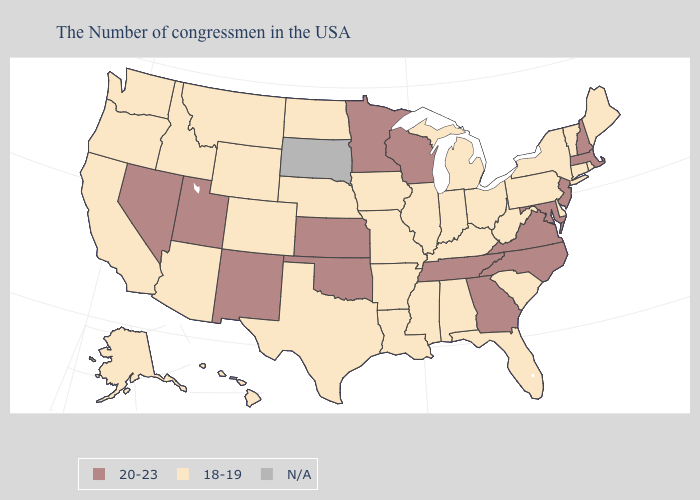Does the first symbol in the legend represent the smallest category?
Write a very short answer. No. Name the states that have a value in the range N/A?
Concise answer only. South Dakota. Name the states that have a value in the range N/A?
Short answer required. South Dakota. Name the states that have a value in the range 18-19?
Quick response, please. Maine, Rhode Island, Vermont, Connecticut, New York, Delaware, Pennsylvania, South Carolina, West Virginia, Ohio, Florida, Michigan, Kentucky, Indiana, Alabama, Illinois, Mississippi, Louisiana, Missouri, Arkansas, Iowa, Nebraska, Texas, North Dakota, Wyoming, Colorado, Montana, Arizona, Idaho, California, Washington, Oregon, Alaska, Hawaii. Does Montana have the lowest value in the West?
Keep it brief. Yes. Name the states that have a value in the range 18-19?
Answer briefly. Maine, Rhode Island, Vermont, Connecticut, New York, Delaware, Pennsylvania, South Carolina, West Virginia, Ohio, Florida, Michigan, Kentucky, Indiana, Alabama, Illinois, Mississippi, Louisiana, Missouri, Arkansas, Iowa, Nebraska, Texas, North Dakota, Wyoming, Colorado, Montana, Arizona, Idaho, California, Washington, Oregon, Alaska, Hawaii. What is the value of Wyoming?
Write a very short answer. 18-19. What is the lowest value in states that border Alabama?
Keep it brief. 18-19. Name the states that have a value in the range 18-19?
Give a very brief answer. Maine, Rhode Island, Vermont, Connecticut, New York, Delaware, Pennsylvania, South Carolina, West Virginia, Ohio, Florida, Michigan, Kentucky, Indiana, Alabama, Illinois, Mississippi, Louisiana, Missouri, Arkansas, Iowa, Nebraska, Texas, North Dakota, Wyoming, Colorado, Montana, Arizona, Idaho, California, Washington, Oregon, Alaska, Hawaii. Name the states that have a value in the range 20-23?
Short answer required. Massachusetts, New Hampshire, New Jersey, Maryland, Virginia, North Carolina, Georgia, Tennessee, Wisconsin, Minnesota, Kansas, Oklahoma, New Mexico, Utah, Nevada. What is the value of Oregon?
Concise answer only. 18-19. How many symbols are there in the legend?
Be succinct. 3. Name the states that have a value in the range 20-23?
Keep it brief. Massachusetts, New Hampshire, New Jersey, Maryland, Virginia, North Carolina, Georgia, Tennessee, Wisconsin, Minnesota, Kansas, Oklahoma, New Mexico, Utah, Nevada. 